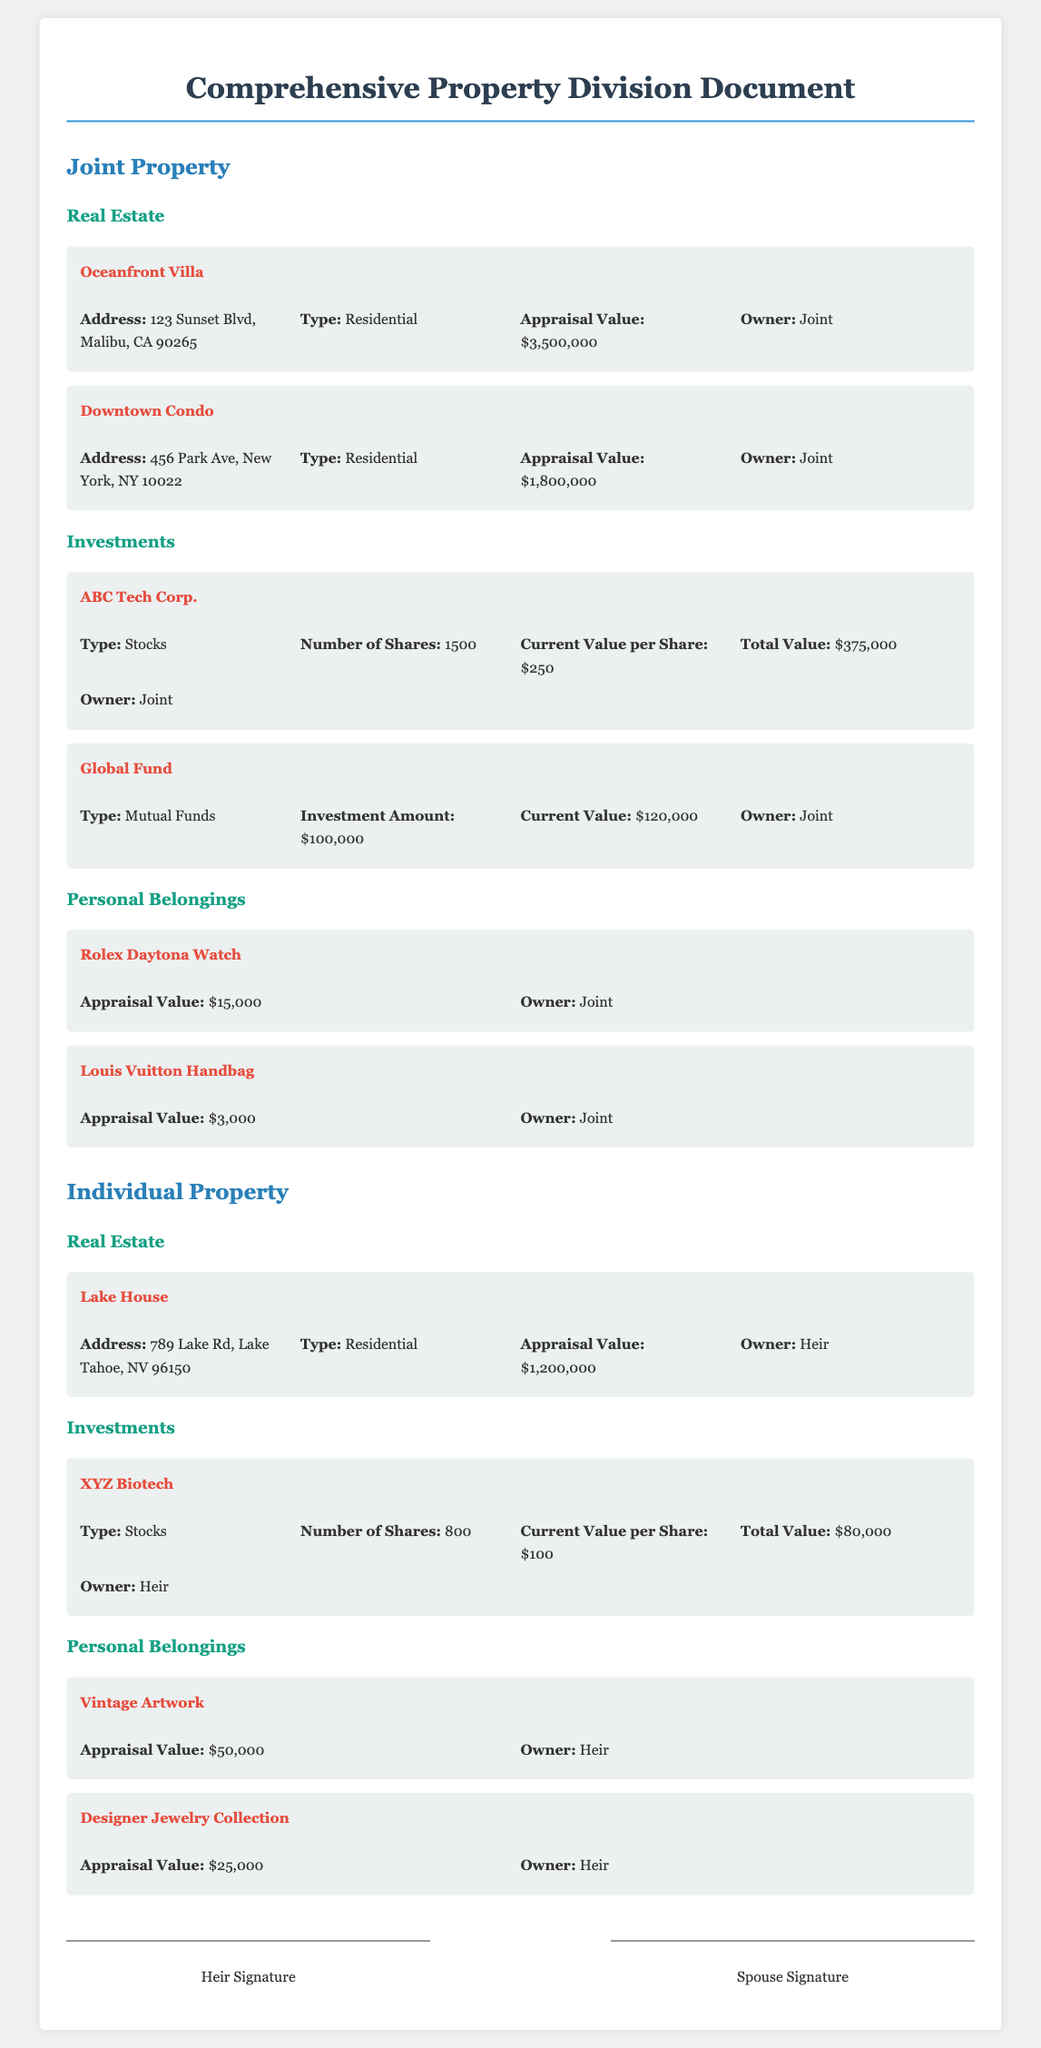What is the appraisal value of the Oceanfront Villa? The appraisal value for the Oceanfront Villa is listed under joint property in the document.
Answer: $3,500,000 How many shares of ABC Tech Corp. are there? The document specifies the number of shares owned in the ABC Tech Corp. investment section.
Answer: 1500 What is the total value of the Global Fund investment? The total value of the Global Fund can be found in the investment section for joint property.
Answer: $120,000 Who is the owner of the Lake House? The owner is mentioned specifically in the section for individual property under the real estate category.
Answer: Heir What is the appraisal value of the Designer Jewelry Collection? The appraisal value is noted in the personal belongings section for individual property.
Answer: $25,000 What type of property is the Downtown Condo? The property type is categorized in the real estate section of the joint property area.
Answer: Residential How much is the appraisal value of the Rolex Daytona Watch? The appraisal value is provided under personal belongings in the joint property section.
Answer: $15,000 How many shares of XYZ Biotech does the heir own? The document states the number of shares held in the XYZ Biotech investment section.
Answer: 800 What is the address of the Downtown Condo? The address for the Downtown Condo can be found in the joint property real estate section.
Answer: 456 Park Ave, New York, NY 10022 